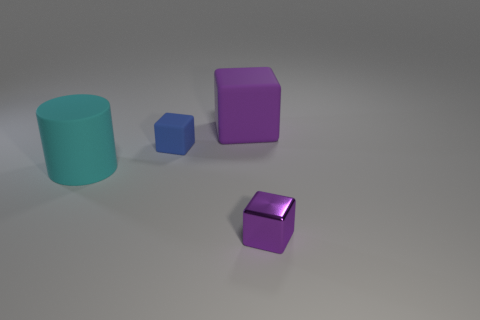Are there any other things that are the same material as the small purple thing?
Make the answer very short. No. The big thing in front of the big matte thing right of the blue thing is what color?
Your answer should be very brief. Cyan. There is a tiny object behind the small purple metal block; does it have the same shape as the purple thing that is in front of the large cylinder?
Provide a short and direct response. Yes. What shape is the blue matte thing that is the same size as the purple metal cube?
Your response must be concise. Cube. What is the color of the other big thing that is made of the same material as the big cyan thing?
Provide a succinct answer. Purple. Do the big purple object and the tiny thing on the left side of the small purple thing have the same shape?
Keep it short and to the point. Yes. What is the material of the block that is the same color as the metal thing?
Offer a very short reply. Rubber. There is a cyan thing that is the same size as the purple matte object; what material is it?
Offer a very short reply. Rubber. Is there another cylinder that has the same color as the rubber cylinder?
Provide a short and direct response. No. There is a thing that is behind the small purple metal thing and to the right of the blue rubber thing; what shape is it?
Your response must be concise. Cube. 